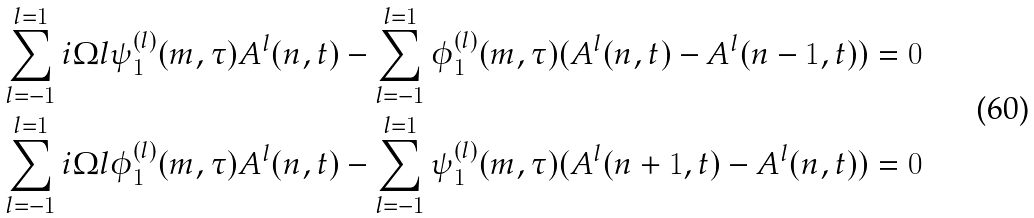Convert formula to latex. <formula><loc_0><loc_0><loc_500><loc_500>& \sum _ { l = - 1 } ^ { l = 1 } i \Omega l \psi _ { 1 } ^ { ( l ) } ( m , \tau ) A ^ { l } ( n , t ) - \sum _ { l = - 1 } ^ { l = 1 } \phi _ { 1 } ^ { ( l ) } ( m , \tau ) ( A ^ { l } ( n , t ) - A ^ { l } ( n - 1 , t ) ) = 0 \\ & \sum _ { l = - 1 } ^ { l = 1 } i \Omega l \phi _ { 1 } ^ { ( l ) } ( m , \tau ) A ^ { l } ( n , t ) - \sum _ { l = - 1 } ^ { l = 1 } \psi _ { 1 } ^ { ( l ) } ( m , \tau ) ( A ^ { l } ( n + 1 , t ) - A ^ { l } ( n , t ) ) = 0</formula> 